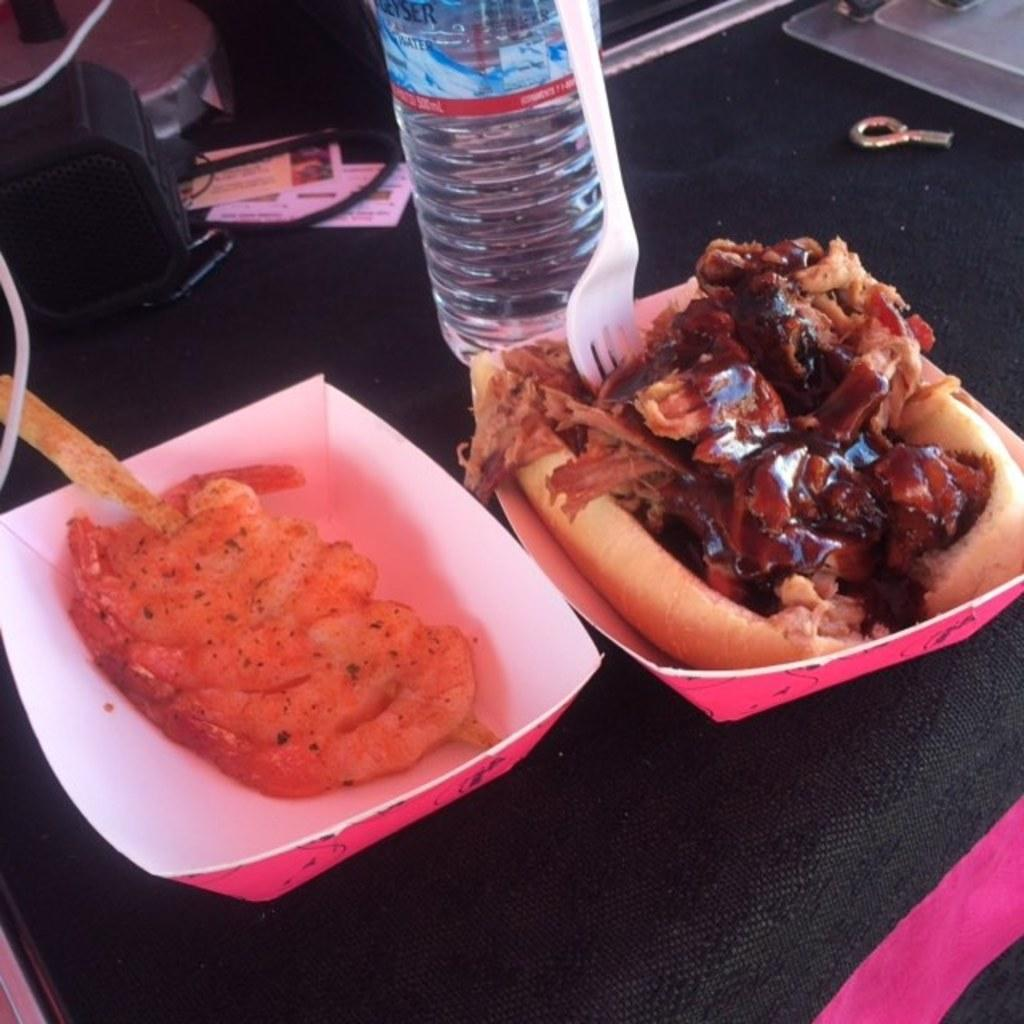What is the food served on in the image? The food is served on paper plates in the image. What is located beside the plates in the image? There is a bottle beside the plates in the image. Can you describe any other objects in the image? There are other unspecified things in the image, but we cannot provide specific details without more information. What utensil is present in the image? There is a fork in the image. What type of kite is being flown in the image? There is no kite present in the image; it only features food on paper plates, a bottle, and a fork. Can you tell me how many harbors are visible in the image? There are no harbors visible in the image; it does not depict any maritime scenes or structures. 